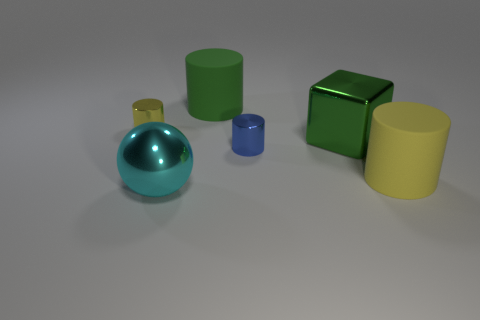Add 1 small shiny objects. How many objects exist? 7 Subtract all cubes. How many objects are left? 5 Add 4 small blue shiny cylinders. How many small blue shiny cylinders exist? 5 Subtract 1 cyan spheres. How many objects are left? 5 Subtract all metallic blocks. Subtract all green matte cylinders. How many objects are left? 4 Add 4 big cylinders. How many big cylinders are left? 6 